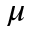<formula> <loc_0><loc_0><loc_500><loc_500>\mu</formula> 